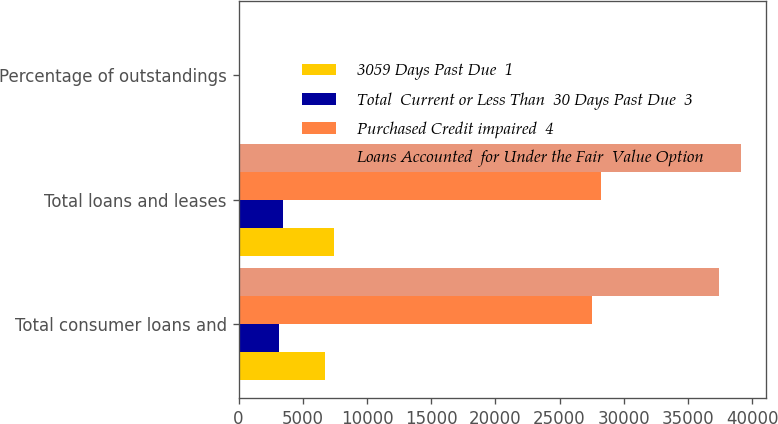<chart> <loc_0><loc_0><loc_500><loc_500><stacked_bar_chart><ecel><fcel>Total consumer loans and<fcel>Total loans and leases<fcel>Percentage of outstandings<nl><fcel>3059 Days Past Due  1<fcel>6712<fcel>7405<fcel>0.8<nl><fcel>Total  Current or Less Than  30 Days Past Due  3<fcel>3159<fcel>3439<fcel>0.37<nl><fcel>Purchased Credit impaired  4<fcel>27533<fcel>28263<fcel>3.04<nl><fcel>Loans Accounted  for Under the Fair  Value Option<fcel>37404<fcel>39107<fcel>4.21<nl></chart> 